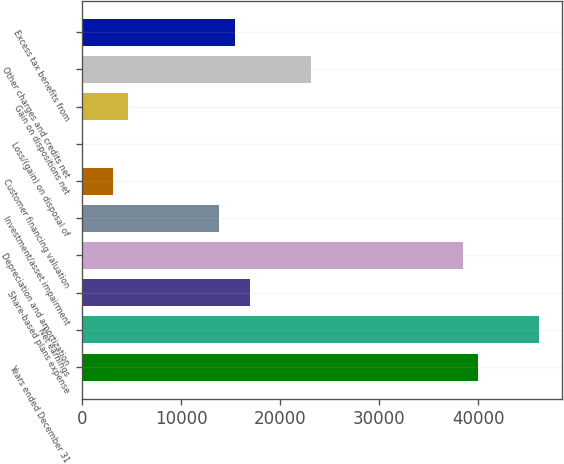Convert chart. <chart><loc_0><loc_0><loc_500><loc_500><bar_chart><fcel>Years ended December 31<fcel>Net earnings<fcel>Share-based plans expense<fcel>Depreciation and amortization<fcel>Investment/asset impairment<fcel>Customer financing valuation<fcel>Loss/(gain) on disposal of<fcel>Gain on dispositions net<fcel>Other charges and credits net<fcel>Excess tax benefits from<nl><fcel>40022.8<fcel>46180<fcel>16933.3<fcel>38483.5<fcel>13854.7<fcel>3079.6<fcel>1<fcel>4618.9<fcel>23090.5<fcel>15394<nl></chart> 